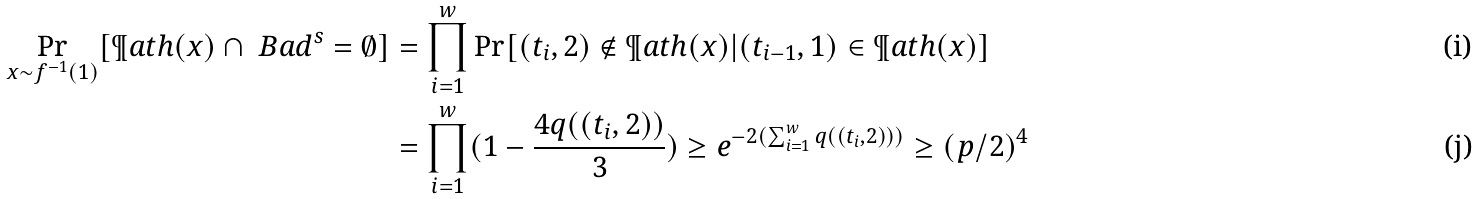Convert formula to latex. <formula><loc_0><loc_0><loc_500><loc_500>\Pr _ { x \sim f ^ { - 1 } ( 1 ) } [ \P a t h ( x ) \cap \ B a d ^ { s } = \emptyset ] & = \prod _ { i = 1 } ^ { w } \Pr [ ( t _ { i } , 2 ) \not \in \P a t h ( x ) | ( t _ { i - 1 } , 1 ) \in \P a t h ( x ) ] \\ & = \prod _ { i = 1 } ^ { w } ( 1 - \frac { 4 q ( ( t _ { i } , 2 ) ) } { 3 } ) \geq e ^ { - 2 ( \sum _ { i = 1 } ^ { w } q ( ( t _ { i } , 2 ) ) ) } \geq ( p / 2 ) ^ { 4 }</formula> 